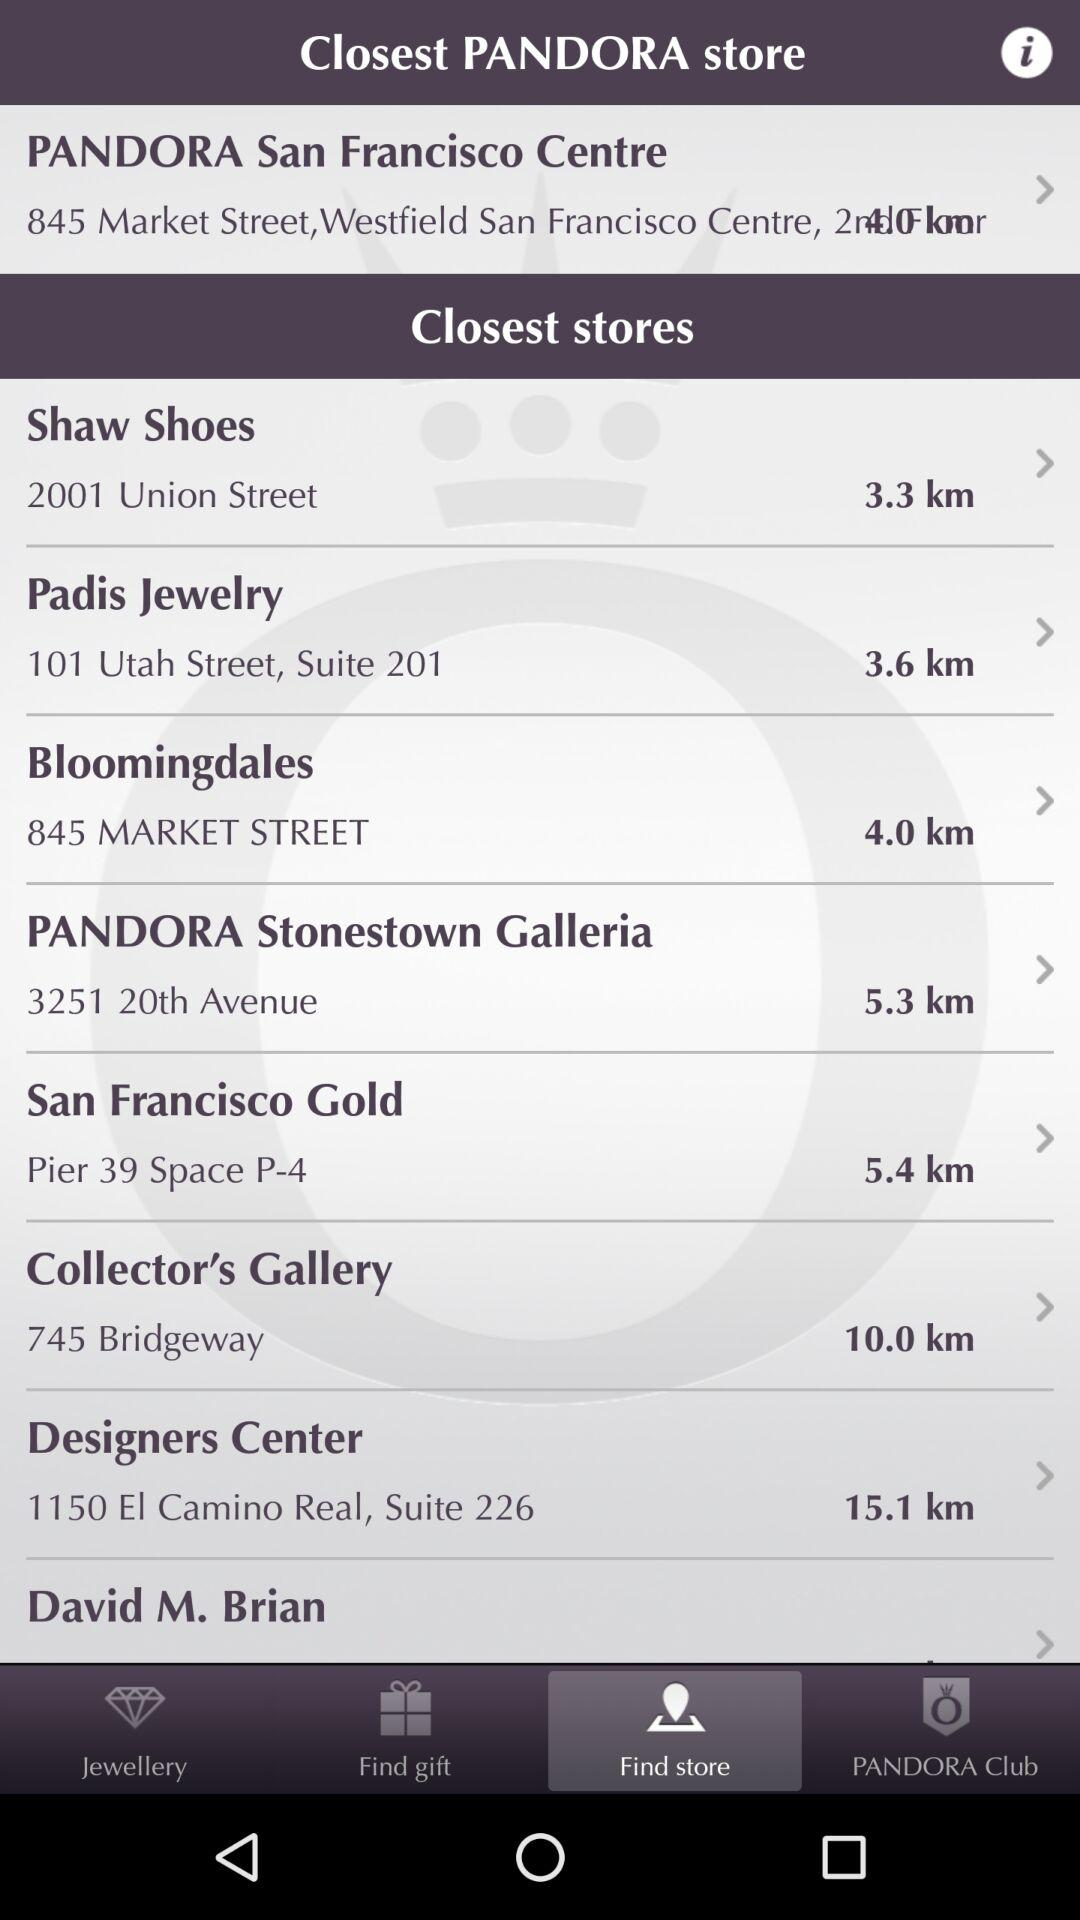What is the address of the "PANDORA San Francisco Centre"? The address is 845 Market Street, Westfield San Francisco Centre. 